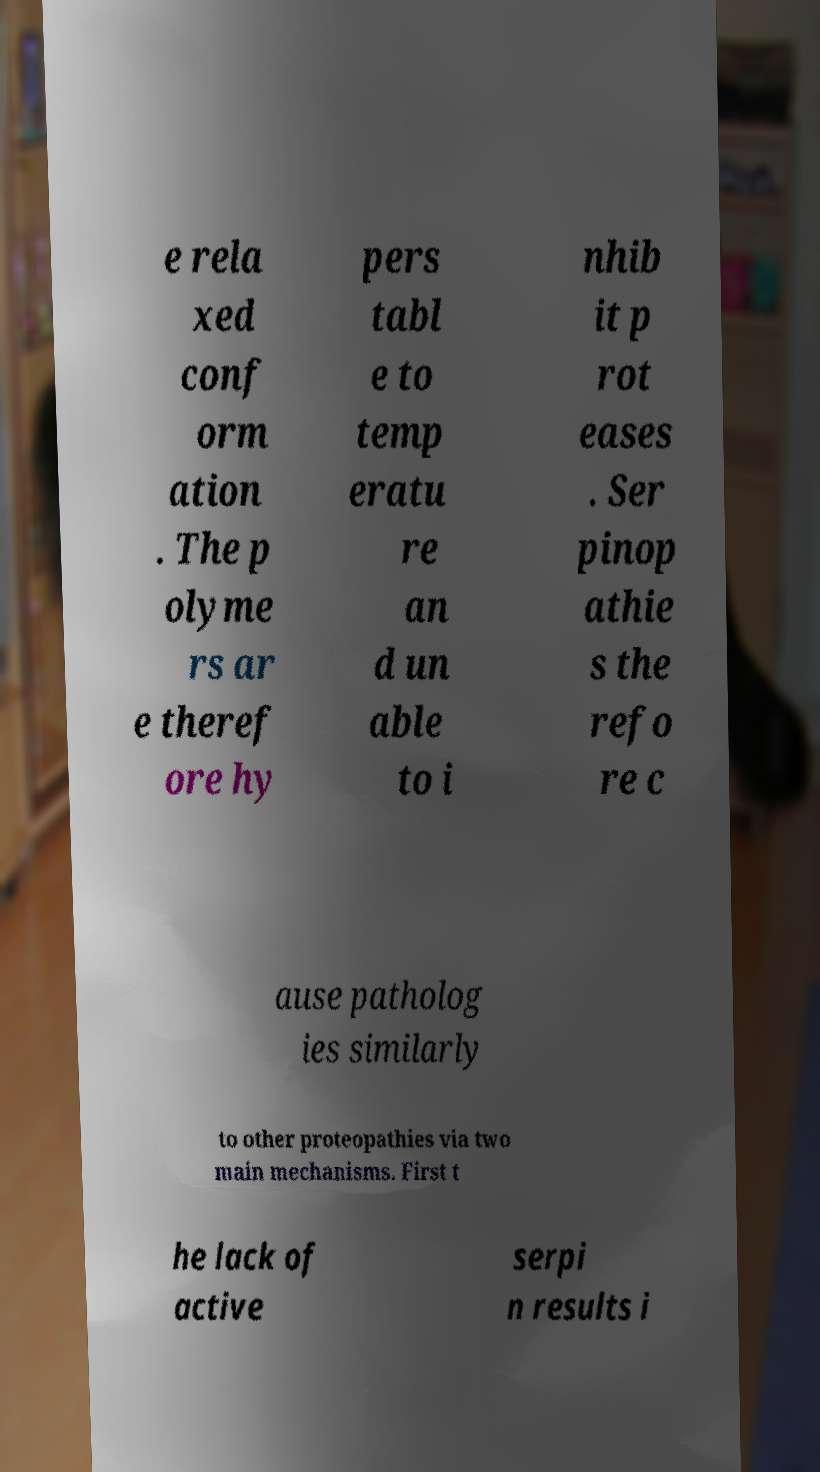I need the written content from this picture converted into text. Can you do that? e rela xed conf orm ation . The p olyme rs ar e theref ore hy pers tabl e to temp eratu re an d un able to i nhib it p rot eases . Ser pinop athie s the refo re c ause patholog ies similarly to other proteopathies via two main mechanisms. First t he lack of active serpi n results i 